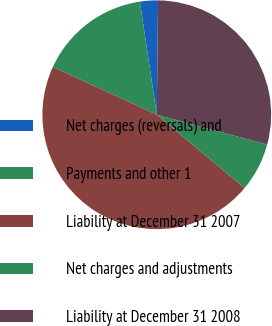Convert chart to OTSL. <chart><loc_0><loc_0><loc_500><loc_500><pie_chart><fcel>Net charges (reversals) and<fcel>Payments and other 1<fcel>Liability at December 31 2007<fcel>Net charges and adjustments<fcel>Liability at December 31 2008<nl><fcel>2.54%<fcel>15.78%<fcel>45.8%<fcel>6.87%<fcel>29.01%<nl></chart> 